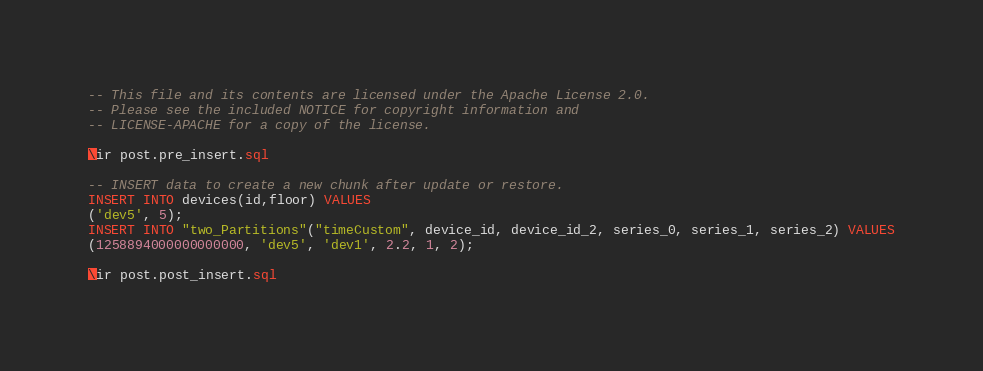Convert code to text. <code><loc_0><loc_0><loc_500><loc_500><_SQL_>-- This file and its contents are licensed under the Apache License 2.0.
-- Please see the included NOTICE for copyright information and
-- LICENSE-APACHE for a copy of the license.

\ir post.pre_insert.sql

-- INSERT data to create a new chunk after update or restore.
INSERT INTO devices(id,floor) VALUES
('dev5', 5);
INSERT INTO "two_Partitions"("timeCustom", device_id, device_id_2, series_0, series_1, series_2) VALUES
(1258894000000000000, 'dev5', 'dev1', 2.2, 1, 2);

\ir post.post_insert.sql
</code> 